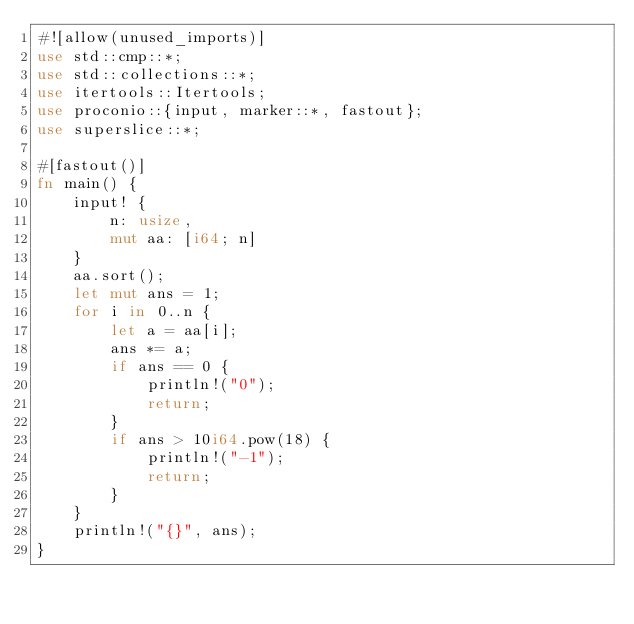Convert code to text. <code><loc_0><loc_0><loc_500><loc_500><_Rust_>#![allow(unused_imports)]
use std::cmp::*;
use std::collections::*;
use itertools::Itertools;
use proconio::{input, marker::*, fastout};
use superslice::*;

#[fastout()]
fn main() {
    input! {
        n: usize,
        mut aa: [i64; n]
    }
    aa.sort();
    let mut ans = 1;
    for i in 0..n {
        let a = aa[i];
        ans *= a;
        if ans == 0 {
            println!("0");
            return;
        }
        if ans > 10i64.pow(18) {
            println!("-1");
            return;
        }
    }
    println!("{}", ans);
}
</code> 